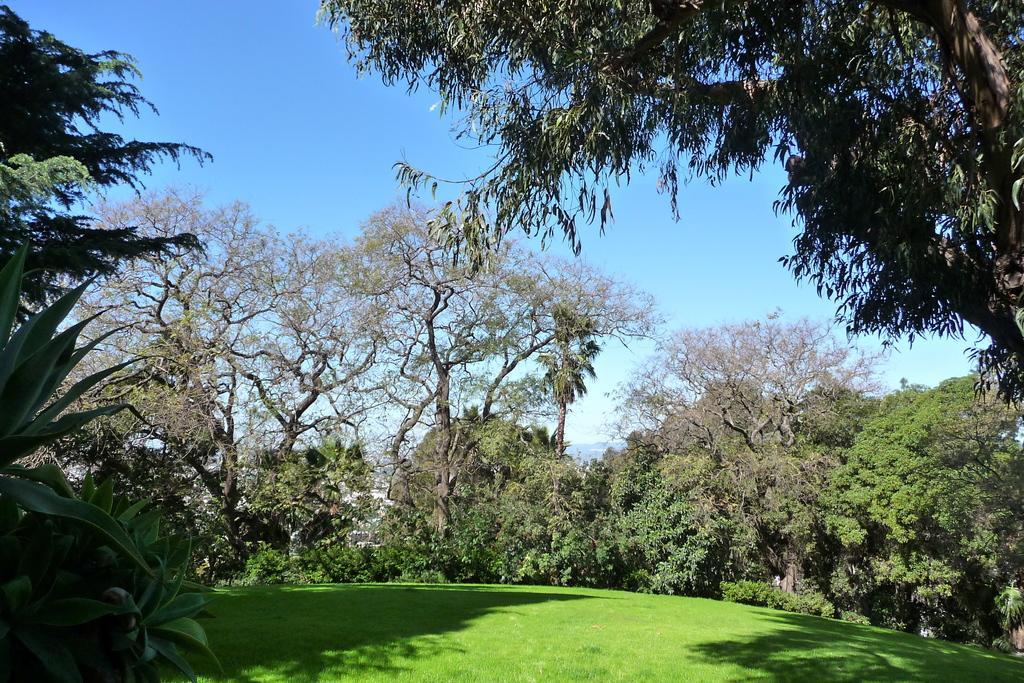How would you summarize this image in a sentence or two? In this picture we can see many trees, plants and grass. In the background we can see the buildings. At the top there is a sky. 